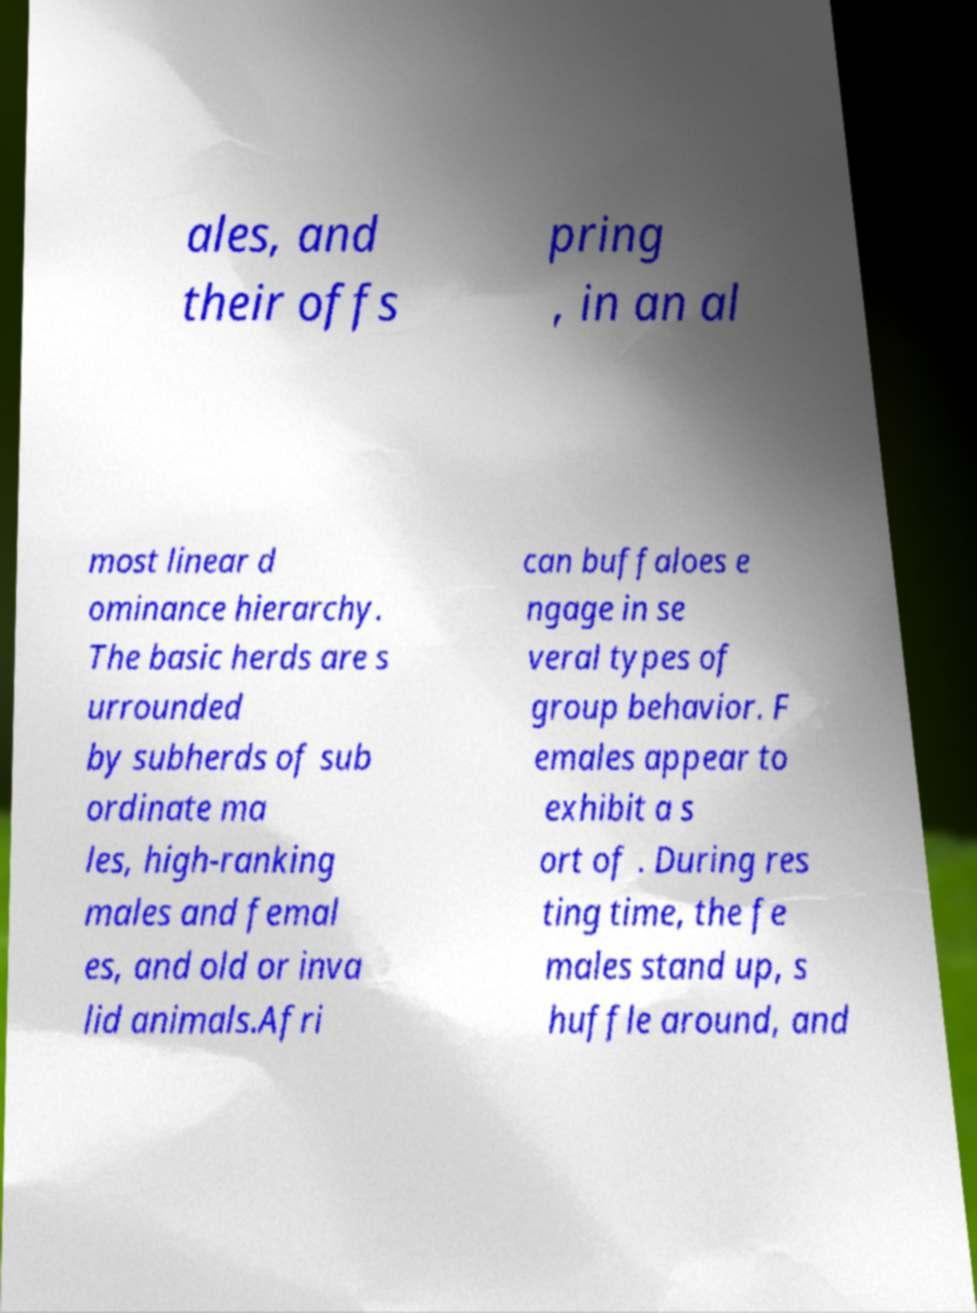Can you accurately transcribe the text from the provided image for me? ales, and their offs pring , in an al most linear d ominance hierarchy. The basic herds are s urrounded by subherds of sub ordinate ma les, high-ranking males and femal es, and old or inva lid animals.Afri can buffaloes e ngage in se veral types of group behavior. F emales appear to exhibit a s ort of . During res ting time, the fe males stand up, s huffle around, and 